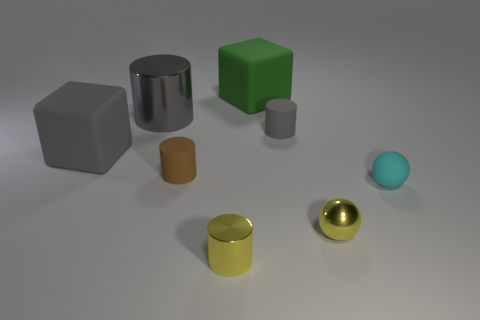Subtract all small gray rubber cylinders. How many cylinders are left? 3 Subtract all red spheres. How many gray cylinders are left? 2 Subtract all brown cylinders. How many cylinders are left? 3 Add 1 gray metallic cylinders. How many objects exist? 9 Subtract all green cylinders. Subtract all green blocks. How many cylinders are left? 4 Subtract all spheres. How many objects are left? 6 Subtract all blue metal cubes. Subtract all yellow spheres. How many objects are left? 7 Add 3 large gray cubes. How many large gray cubes are left? 4 Add 6 small brown objects. How many small brown objects exist? 7 Subtract 0 red cylinders. How many objects are left? 8 